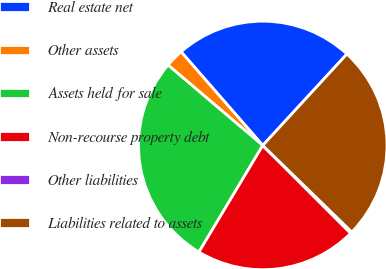<chart> <loc_0><loc_0><loc_500><loc_500><pie_chart><fcel>Real estate net<fcel>Other assets<fcel>Assets held for sale<fcel>Non-recourse property debt<fcel>Other liabilities<fcel>Liabilities related to assets<nl><fcel>23.26%<fcel>2.39%<fcel>27.61%<fcel>21.09%<fcel>0.22%<fcel>25.43%<nl></chart> 